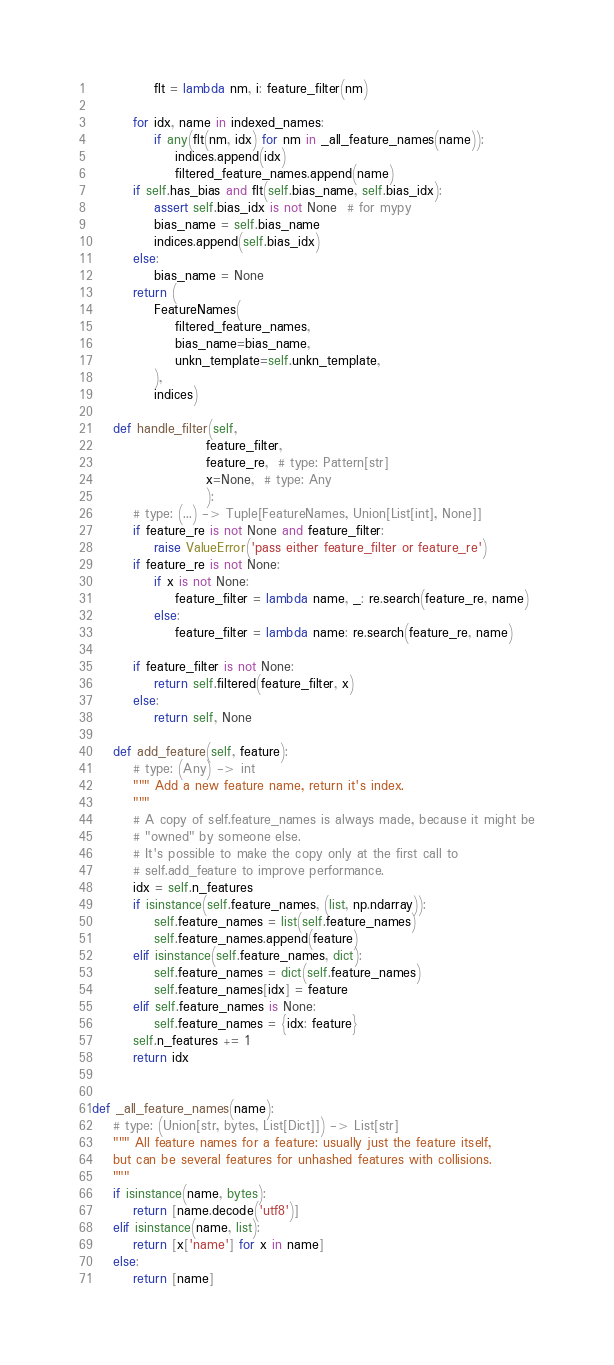<code> <loc_0><loc_0><loc_500><loc_500><_Python_>            flt = lambda nm, i: feature_filter(nm)

        for idx, name in indexed_names:
            if any(flt(nm, idx) for nm in _all_feature_names(name)):
                indices.append(idx)
                filtered_feature_names.append(name)
        if self.has_bias and flt(self.bias_name, self.bias_idx):
            assert self.bias_idx is not None  # for mypy
            bias_name = self.bias_name
            indices.append(self.bias_idx)
        else:
            bias_name = None
        return (
            FeatureNames(
                filtered_feature_names,
                bias_name=bias_name,
                unkn_template=self.unkn_template,
            ),
            indices)

    def handle_filter(self,
                      feature_filter,
                      feature_re,  # type: Pattern[str]
                      x=None,  # type: Any
                      ):
        # type: (...) -> Tuple[FeatureNames, Union[List[int], None]]
        if feature_re is not None and feature_filter:
            raise ValueError('pass either feature_filter or feature_re')
        if feature_re is not None:
            if x is not None:
                feature_filter = lambda name, _: re.search(feature_re, name)
            else:
                feature_filter = lambda name: re.search(feature_re, name)

        if feature_filter is not None:
            return self.filtered(feature_filter, x)
        else:
            return self, None

    def add_feature(self, feature):
        # type: (Any) -> int
        """ Add a new feature name, return it's index.
        """
        # A copy of self.feature_names is always made, because it might be
        # "owned" by someone else.
        # It's possible to make the copy only at the first call to
        # self.add_feature to improve performance.
        idx = self.n_features
        if isinstance(self.feature_names, (list, np.ndarray)):
            self.feature_names = list(self.feature_names)
            self.feature_names.append(feature)
        elif isinstance(self.feature_names, dict):
            self.feature_names = dict(self.feature_names)
            self.feature_names[idx] = feature
        elif self.feature_names is None:
            self.feature_names = {idx: feature}
        self.n_features += 1
        return idx


def _all_feature_names(name):
    # type: (Union[str, bytes, List[Dict]]) -> List[str]
    """ All feature names for a feature: usually just the feature itself,
    but can be several features for unhashed features with collisions.
    """
    if isinstance(name, bytes):
        return [name.decode('utf8')]
    elif isinstance(name, list):
        return [x['name'] for x in name]
    else:
        return [name]
</code> 